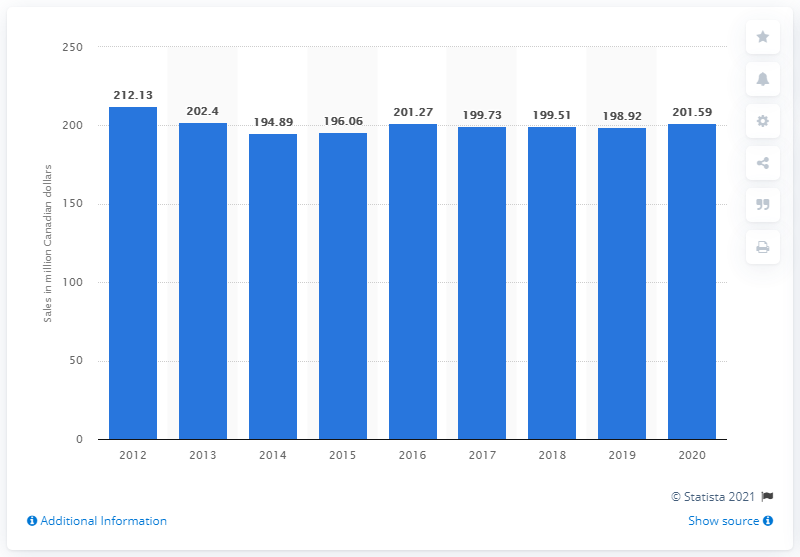Specify some key components in this picture. In 2020, the sales of beer in New Brunswick were $201.59 million. In 2019, the sales of beer in New Brunswick totaled 198.92 million dollars. 